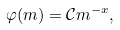Convert formula to latex. <formula><loc_0><loc_0><loc_500><loc_500>\varphi ( m ) = { \mathcal { C } } m ^ { - x } ,</formula> 